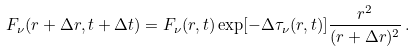Convert formula to latex. <formula><loc_0><loc_0><loc_500><loc_500>F _ { \nu } ( r + \Delta r , t + \Delta t ) = F _ { \nu } ( r , t ) \exp [ - \Delta \tau _ { \nu } ( r , t ) ] \frac { r ^ { 2 } } { ( r + \Delta r ) ^ { 2 } } \, .</formula> 